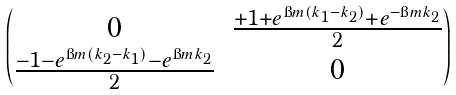<formula> <loc_0><loc_0><loc_500><loc_500>\begin{pmatrix} 0 & \frac { + 1 + e ^ { \i m ( k _ { 1 } - k _ { 2 } ) } + e ^ { - \i m k _ { 2 } } } { 2 } \\ \frac { - 1 - e ^ { \i m ( k _ { 2 } - k _ { 1 } ) } - e ^ { \i m k _ { 2 } } } { 2 } & 0 \end{pmatrix}</formula> 